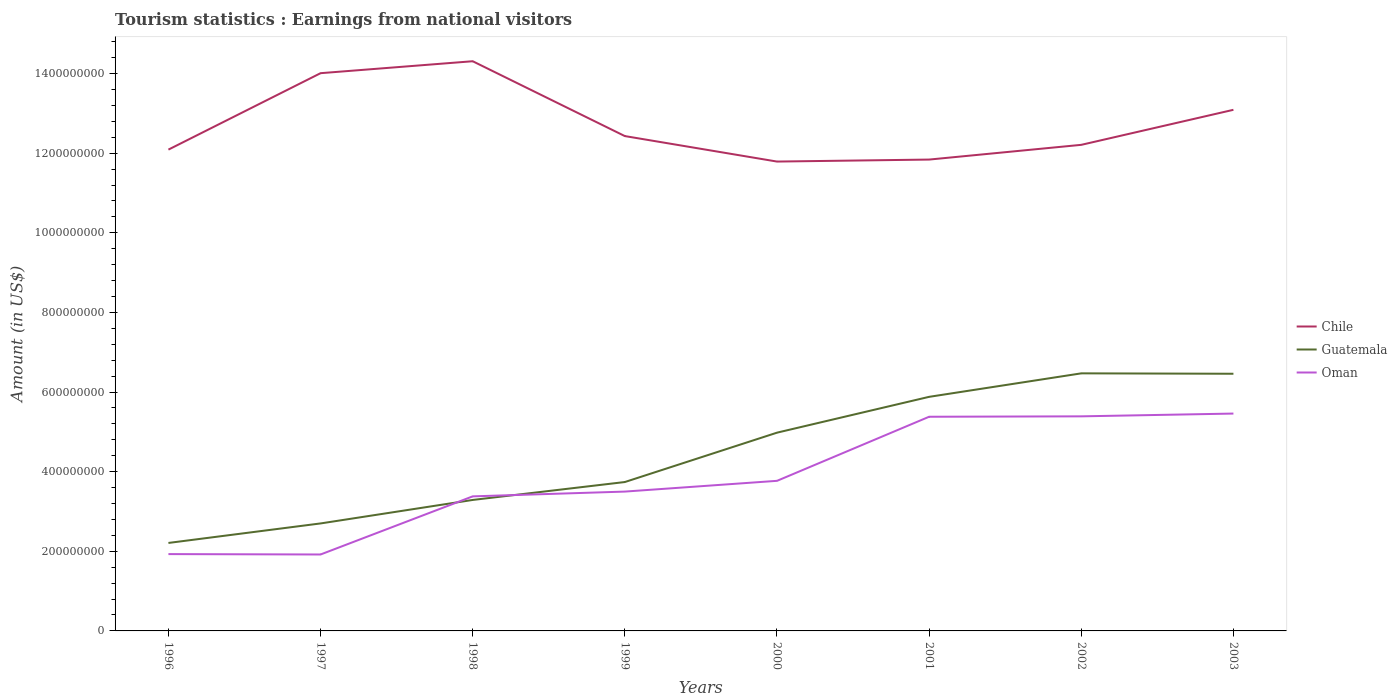Does the line corresponding to Chile intersect with the line corresponding to Guatemala?
Your response must be concise. No. Across all years, what is the maximum earnings from national visitors in Oman?
Keep it short and to the point. 1.92e+08. What is the total earnings from national visitors in Guatemala in the graph?
Offer a terse response. -4.26e+08. What is the difference between the highest and the second highest earnings from national visitors in Chile?
Offer a very short reply. 2.52e+08. Is the earnings from national visitors in Oman strictly greater than the earnings from national visitors in Guatemala over the years?
Make the answer very short. No. How many lines are there?
Give a very brief answer. 3. How many years are there in the graph?
Offer a terse response. 8. What is the difference between two consecutive major ticks on the Y-axis?
Provide a succinct answer. 2.00e+08. Are the values on the major ticks of Y-axis written in scientific E-notation?
Your answer should be very brief. No. Where does the legend appear in the graph?
Make the answer very short. Center right. How many legend labels are there?
Your answer should be very brief. 3. How are the legend labels stacked?
Your response must be concise. Vertical. What is the title of the graph?
Make the answer very short. Tourism statistics : Earnings from national visitors. What is the label or title of the X-axis?
Offer a very short reply. Years. What is the label or title of the Y-axis?
Keep it short and to the point. Amount (in US$). What is the Amount (in US$) of Chile in 1996?
Make the answer very short. 1.21e+09. What is the Amount (in US$) of Guatemala in 1996?
Your answer should be very brief. 2.21e+08. What is the Amount (in US$) in Oman in 1996?
Offer a terse response. 1.93e+08. What is the Amount (in US$) of Chile in 1997?
Your answer should be compact. 1.40e+09. What is the Amount (in US$) in Guatemala in 1997?
Provide a succinct answer. 2.70e+08. What is the Amount (in US$) of Oman in 1997?
Offer a terse response. 1.92e+08. What is the Amount (in US$) of Chile in 1998?
Your response must be concise. 1.43e+09. What is the Amount (in US$) in Guatemala in 1998?
Keep it short and to the point. 3.29e+08. What is the Amount (in US$) in Oman in 1998?
Ensure brevity in your answer.  3.38e+08. What is the Amount (in US$) of Chile in 1999?
Give a very brief answer. 1.24e+09. What is the Amount (in US$) of Guatemala in 1999?
Your answer should be very brief. 3.74e+08. What is the Amount (in US$) of Oman in 1999?
Your answer should be compact. 3.50e+08. What is the Amount (in US$) of Chile in 2000?
Provide a succinct answer. 1.18e+09. What is the Amount (in US$) of Guatemala in 2000?
Provide a succinct answer. 4.98e+08. What is the Amount (in US$) in Oman in 2000?
Your response must be concise. 3.77e+08. What is the Amount (in US$) of Chile in 2001?
Make the answer very short. 1.18e+09. What is the Amount (in US$) in Guatemala in 2001?
Give a very brief answer. 5.88e+08. What is the Amount (in US$) of Oman in 2001?
Provide a succinct answer. 5.38e+08. What is the Amount (in US$) of Chile in 2002?
Provide a succinct answer. 1.22e+09. What is the Amount (in US$) in Guatemala in 2002?
Make the answer very short. 6.47e+08. What is the Amount (in US$) in Oman in 2002?
Ensure brevity in your answer.  5.39e+08. What is the Amount (in US$) of Chile in 2003?
Offer a very short reply. 1.31e+09. What is the Amount (in US$) of Guatemala in 2003?
Give a very brief answer. 6.46e+08. What is the Amount (in US$) of Oman in 2003?
Provide a short and direct response. 5.46e+08. Across all years, what is the maximum Amount (in US$) of Chile?
Keep it short and to the point. 1.43e+09. Across all years, what is the maximum Amount (in US$) of Guatemala?
Your response must be concise. 6.47e+08. Across all years, what is the maximum Amount (in US$) of Oman?
Keep it short and to the point. 5.46e+08. Across all years, what is the minimum Amount (in US$) of Chile?
Offer a very short reply. 1.18e+09. Across all years, what is the minimum Amount (in US$) in Guatemala?
Give a very brief answer. 2.21e+08. Across all years, what is the minimum Amount (in US$) of Oman?
Keep it short and to the point. 1.92e+08. What is the total Amount (in US$) in Chile in the graph?
Offer a terse response. 1.02e+1. What is the total Amount (in US$) of Guatemala in the graph?
Offer a terse response. 3.57e+09. What is the total Amount (in US$) in Oman in the graph?
Your answer should be very brief. 3.07e+09. What is the difference between the Amount (in US$) of Chile in 1996 and that in 1997?
Provide a short and direct response. -1.92e+08. What is the difference between the Amount (in US$) in Guatemala in 1996 and that in 1997?
Provide a short and direct response. -4.90e+07. What is the difference between the Amount (in US$) of Oman in 1996 and that in 1997?
Give a very brief answer. 1.00e+06. What is the difference between the Amount (in US$) of Chile in 1996 and that in 1998?
Your answer should be very brief. -2.22e+08. What is the difference between the Amount (in US$) in Guatemala in 1996 and that in 1998?
Your answer should be compact. -1.08e+08. What is the difference between the Amount (in US$) in Oman in 1996 and that in 1998?
Provide a succinct answer. -1.45e+08. What is the difference between the Amount (in US$) of Chile in 1996 and that in 1999?
Your response must be concise. -3.40e+07. What is the difference between the Amount (in US$) of Guatemala in 1996 and that in 1999?
Your answer should be compact. -1.53e+08. What is the difference between the Amount (in US$) in Oman in 1996 and that in 1999?
Make the answer very short. -1.57e+08. What is the difference between the Amount (in US$) of Chile in 1996 and that in 2000?
Your answer should be compact. 3.00e+07. What is the difference between the Amount (in US$) in Guatemala in 1996 and that in 2000?
Provide a short and direct response. -2.77e+08. What is the difference between the Amount (in US$) in Oman in 1996 and that in 2000?
Provide a succinct answer. -1.84e+08. What is the difference between the Amount (in US$) of Chile in 1996 and that in 2001?
Give a very brief answer. 2.50e+07. What is the difference between the Amount (in US$) of Guatemala in 1996 and that in 2001?
Your answer should be very brief. -3.67e+08. What is the difference between the Amount (in US$) of Oman in 1996 and that in 2001?
Your response must be concise. -3.45e+08. What is the difference between the Amount (in US$) of Chile in 1996 and that in 2002?
Offer a very short reply. -1.20e+07. What is the difference between the Amount (in US$) in Guatemala in 1996 and that in 2002?
Your response must be concise. -4.26e+08. What is the difference between the Amount (in US$) in Oman in 1996 and that in 2002?
Provide a short and direct response. -3.46e+08. What is the difference between the Amount (in US$) in Chile in 1996 and that in 2003?
Make the answer very short. -1.00e+08. What is the difference between the Amount (in US$) in Guatemala in 1996 and that in 2003?
Give a very brief answer. -4.25e+08. What is the difference between the Amount (in US$) in Oman in 1996 and that in 2003?
Your answer should be compact. -3.53e+08. What is the difference between the Amount (in US$) of Chile in 1997 and that in 1998?
Your answer should be very brief. -3.00e+07. What is the difference between the Amount (in US$) in Guatemala in 1997 and that in 1998?
Your answer should be very brief. -5.90e+07. What is the difference between the Amount (in US$) of Oman in 1997 and that in 1998?
Provide a short and direct response. -1.46e+08. What is the difference between the Amount (in US$) in Chile in 1997 and that in 1999?
Your response must be concise. 1.58e+08. What is the difference between the Amount (in US$) of Guatemala in 1997 and that in 1999?
Your response must be concise. -1.04e+08. What is the difference between the Amount (in US$) of Oman in 1997 and that in 1999?
Ensure brevity in your answer.  -1.58e+08. What is the difference between the Amount (in US$) in Chile in 1997 and that in 2000?
Your answer should be very brief. 2.22e+08. What is the difference between the Amount (in US$) of Guatemala in 1997 and that in 2000?
Offer a very short reply. -2.28e+08. What is the difference between the Amount (in US$) in Oman in 1997 and that in 2000?
Your answer should be very brief. -1.85e+08. What is the difference between the Amount (in US$) of Chile in 1997 and that in 2001?
Ensure brevity in your answer.  2.17e+08. What is the difference between the Amount (in US$) of Guatemala in 1997 and that in 2001?
Provide a succinct answer. -3.18e+08. What is the difference between the Amount (in US$) in Oman in 1997 and that in 2001?
Make the answer very short. -3.46e+08. What is the difference between the Amount (in US$) in Chile in 1997 and that in 2002?
Keep it short and to the point. 1.80e+08. What is the difference between the Amount (in US$) of Guatemala in 1997 and that in 2002?
Offer a very short reply. -3.77e+08. What is the difference between the Amount (in US$) in Oman in 1997 and that in 2002?
Provide a short and direct response. -3.47e+08. What is the difference between the Amount (in US$) in Chile in 1997 and that in 2003?
Make the answer very short. 9.20e+07. What is the difference between the Amount (in US$) in Guatemala in 1997 and that in 2003?
Provide a succinct answer. -3.76e+08. What is the difference between the Amount (in US$) in Oman in 1997 and that in 2003?
Keep it short and to the point. -3.54e+08. What is the difference between the Amount (in US$) of Chile in 1998 and that in 1999?
Ensure brevity in your answer.  1.88e+08. What is the difference between the Amount (in US$) in Guatemala in 1998 and that in 1999?
Your response must be concise. -4.50e+07. What is the difference between the Amount (in US$) of Oman in 1998 and that in 1999?
Offer a terse response. -1.20e+07. What is the difference between the Amount (in US$) in Chile in 1998 and that in 2000?
Provide a succinct answer. 2.52e+08. What is the difference between the Amount (in US$) of Guatemala in 1998 and that in 2000?
Offer a terse response. -1.69e+08. What is the difference between the Amount (in US$) of Oman in 1998 and that in 2000?
Offer a terse response. -3.90e+07. What is the difference between the Amount (in US$) of Chile in 1998 and that in 2001?
Your answer should be very brief. 2.47e+08. What is the difference between the Amount (in US$) of Guatemala in 1998 and that in 2001?
Provide a succinct answer. -2.59e+08. What is the difference between the Amount (in US$) of Oman in 1998 and that in 2001?
Offer a very short reply. -2.00e+08. What is the difference between the Amount (in US$) in Chile in 1998 and that in 2002?
Give a very brief answer. 2.10e+08. What is the difference between the Amount (in US$) in Guatemala in 1998 and that in 2002?
Make the answer very short. -3.18e+08. What is the difference between the Amount (in US$) of Oman in 1998 and that in 2002?
Give a very brief answer. -2.01e+08. What is the difference between the Amount (in US$) of Chile in 1998 and that in 2003?
Provide a succinct answer. 1.22e+08. What is the difference between the Amount (in US$) of Guatemala in 1998 and that in 2003?
Provide a short and direct response. -3.17e+08. What is the difference between the Amount (in US$) of Oman in 1998 and that in 2003?
Ensure brevity in your answer.  -2.08e+08. What is the difference between the Amount (in US$) in Chile in 1999 and that in 2000?
Offer a very short reply. 6.40e+07. What is the difference between the Amount (in US$) in Guatemala in 1999 and that in 2000?
Provide a succinct answer. -1.24e+08. What is the difference between the Amount (in US$) in Oman in 1999 and that in 2000?
Your response must be concise. -2.70e+07. What is the difference between the Amount (in US$) in Chile in 1999 and that in 2001?
Offer a terse response. 5.90e+07. What is the difference between the Amount (in US$) in Guatemala in 1999 and that in 2001?
Your answer should be very brief. -2.14e+08. What is the difference between the Amount (in US$) of Oman in 1999 and that in 2001?
Your answer should be very brief. -1.88e+08. What is the difference between the Amount (in US$) of Chile in 1999 and that in 2002?
Keep it short and to the point. 2.20e+07. What is the difference between the Amount (in US$) of Guatemala in 1999 and that in 2002?
Your answer should be compact. -2.73e+08. What is the difference between the Amount (in US$) of Oman in 1999 and that in 2002?
Offer a very short reply. -1.89e+08. What is the difference between the Amount (in US$) in Chile in 1999 and that in 2003?
Give a very brief answer. -6.60e+07. What is the difference between the Amount (in US$) of Guatemala in 1999 and that in 2003?
Your answer should be very brief. -2.72e+08. What is the difference between the Amount (in US$) in Oman in 1999 and that in 2003?
Your answer should be compact. -1.96e+08. What is the difference between the Amount (in US$) in Chile in 2000 and that in 2001?
Your answer should be compact. -5.00e+06. What is the difference between the Amount (in US$) in Guatemala in 2000 and that in 2001?
Provide a succinct answer. -9.00e+07. What is the difference between the Amount (in US$) of Oman in 2000 and that in 2001?
Your answer should be very brief. -1.61e+08. What is the difference between the Amount (in US$) of Chile in 2000 and that in 2002?
Offer a terse response. -4.20e+07. What is the difference between the Amount (in US$) of Guatemala in 2000 and that in 2002?
Your answer should be very brief. -1.49e+08. What is the difference between the Amount (in US$) in Oman in 2000 and that in 2002?
Keep it short and to the point. -1.62e+08. What is the difference between the Amount (in US$) of Chile in 2000 and that in 2003?
Make the answer very short. -1.30e+08. What is the difference between the Amount (in US$) of Guatemala in 2000 and that in 2003?
Your answer should be compact. -1.48e+08. What is the difference between the Amount (in US$) in Oman in 2000 and that in 2003?
Offer a very short reply. -1.69e+08. What is the difference between the Amount (in US$) of Chile in 2001 and that in 2002?
Make the answer very short. -3.70e+07. What is the difference between the Amount (in US$) in Guatemala in 2001 and that in 2002?
Your response must be concise. -5.90e+07. What is the difference between the Amount (in US$) in Chile in 2001 and that in 2003?
Offer a very short reply. -1.25e+08. What is the difference between the Amount (in US$) in Guatemala in 2001 and that in 2003?
Offer a terse response. -5.80e+07. What is the difference between the Amount (in US$) of Oman in 2001 and that in 2003?
Keep it short and to the point. -8.00e+06. What is the difference between the Amount (in US$) of Chile in 2002 and that in 2003?
Provide a short and direct response. -8.80e+07. What is the difference between the Amount (in US$) of Guatemala in 2002 and that in 2003?
Your answer should be compact. 1.00e+06. What is the difference between the Amount (in US$) of Oman in 2002 and that in 2003?
Provide a short and direct response. -7.00e+06. What is the difference between the Amount (in US$) of Chile in 1996 and the Amount (in US$) of Guatemala in 1997?
Provide a short and direct response. 9.39e+08. What is the difference between the Amount (in US$) in Chile in 1996 and the Amount (in US$) in Oman in 1997?
Offer a very short reply. 1.02e+09. What is the difference between the Amount (in US$) of Guatemala in 1996 and the Amount (in US$) of Oman in 1997?
Provide a succinct answer. 2.90e+07. What is the difference between the Amount (in US$) of Chile in 1996 and the Amount (in US$) of Guatemala in 1998?
Your answer should be compact. 8.80e+08. What is the difference between the Amount (in US$) in Chile in 1996 and the Amount (in US$) in Oman in 1998?
Provide a succinct answer. 8.71e+08. What is the difference between the Amount (in US$) of Guatemala in 1996 and the Amount (in US$) of Oman in 1998?
Your answer should be compact. -1.17e+08. What is the difference between the Amount (in US$) of Chile in 1996 and the Amount (in US$) of Guatemala in 1999?
Make the answer very short. 8.35e+08. What is the difference between the Amount (in US$) in Chile in 1996 and the Amount (in US$) in Oman in 1999?
Your answer should be very brief. 8.59e+08. What is the difference between the Amount (in US$) in Guatemala in 1996 and the Amount (in US$) in Oman in 1999?
Your response must be concise. -1.29e+08. What is the difference between the Amount (in US$) of Chile in 1996 and the Amount (in US$) of Guatemala in 2000?
Offer a very short reply. 7.11e+08. What is the difference between the Amount (in US$) of Chile in 1996 and the Amount (in US$) of Oman in 2000?
Ensure brevity in your answer.  8.32e+08. What is the difference between the Amount (in US$) in Guatemala in 1996 and the Amount (in US$) in Oman in 2000?
Ensure brevity in your answer.  -1.56e+08. What is the difference between the Amount (in US$) in Chile in 1996 and the Amount (in US$) in Guatemala in 2001?
Make the answer very short. 6.21e+08. What is the difference between the Amount (in US$) in Chile in 1996 and the Amount (in US$) in Oman in 2001?
Offer a very short reply. 6.71e+08. What is the difference between the Amount (in US$) in Guatemala in 1996 and the Amount (in US$) in Oman in 2001?
Make the answer very short. -3.17e+08. What is the difference between the Amount (in US$) in Chile in 1996 and the Amount (in US$) in Guatemala in 2002?
Keep it short and to the point. 5.62e+08. What is the difference between the Amount (in US$) of Chile in 1996 and the Amount (in US$) of Oman in 2002?
Give a very brief answer. 6.70e+08. What is the difference between the Amount (in US$) in Guatemala in 1996 and the Amount (in US$) in Oman in 2002?
Make the answer very short. -3.18e+08. What is the difference between the Amount (in US$) in Chile in 1996 and the Amount (in US$) in Guatemala in 2003?
Keep it short and to the point. 5.63e+08. What is the difference between the Amount (in US$) of Chile in 1996 and the Amount (in US$) of Oman in 2003?
Provide a succinct answer. 6.63e+08. What is the difference between the Amount (in US$) of Guatemala in 1996 and the Amount (in US$) of Oman in 2003?
Offer a terse response. -3.25e+08. What is the difference between the Amount (in US$) of Chile in 1997 and the Amount (in US$) of Guatemala in 1998?
Provide a short and direct response. 1.07e+09. What is the difference between the Amount (in US$) of Chile in 1997 and the Amount (in US$) of Oman in 1998?
Keep it short and to the point. 1.06e+09. What is the difference between the Amount (in US$) in Guatemala in 1997 and the Amount (in US$) in Oman in 1998?
Make the answer very short. -6.80e+07. What is the difference between the Amount (in US$) in Chile in 1997 and the Amount (in US$) in Guatemala in 1999?
Your answer should be compact. 1.03e+09. What is the difference between the Amount (in US$) of Chile in 1997 and the Amount (in US$) of Oman in 1999?
Your response must be concise. 1.05e+09. What is the difference between the Amount (in US$) in Guatemala in 1997 and the Amount (in US$) in Oman in 1999?
Your response must be concise. -8.00e+07. What is the difference between the Amount (in US$) of Chile in 1997 and the Amount (in US$) of Guatemala in 2000?
Keep it short and to the point. 9.03e+08. What is the difference between the Amount (in US$) in Chile in 1997 and the Amount (in US$) in Oman in 2000?
Your answer should be very brief. 1.02e+09. What is the difference between the Amount (in US$) in Guatemala in 1997 and the Amount (in US$) in Oman in 2000?
Your response must be concise. -1.07e+08. What is the difference between the Amount (in US$) of Chile in 1997 and the Amount (in US$) of Guatemala in 2001?
Make the answer very short. 8.13e+08. What is the difference between the Amount (in US$) of Chile in 1997 and the Amount (in US$) of Oman in 2001?
Ensure brevity in your answer.  8.63e+08. What is the difference between the Amount (in US$) in Guatemala in 1997 and the Amount (in US$) in Oman in 2001?
Your answer should be compact. -2.68e+08. What is the difference between the Amount (in US$) of Chile in 1997 and the Amount (in US$) of Guatemala in 2002?
Offer a very short reply. 7.54e+08. What is the difference between the Amount (in US$) of Chile in 1997 and the Amount (in US$) of Oman in 2002?
Provide a short and direct response. 8.62e+08. What is the difference between the Amount (in US$) in Guatemala in 1997 and the Amount (in US$) in Oman in 2002?
Make the answer very short. -2.69e+08. What is the difference between the Amount (in US$) of Chile in 1997 and the Amount (in US$) of Guatemala in 2003?
Your response must be concise. 7.55e+08. What is the difference between the Amount (in US$) in Chile in 1997 and the Amount (in US$) in Oman in 2003?
Your answer should be very brief. 8.55e+08. What is the difference between the Amount (in US$) of Guatemala in 1997 and the Amount (in US$) of Oman in 2003?
Offer a terse response. -2.76e+08. What is the difference between the Amount (in US$) of Chile in 1998 and the Amount (in US$) of Guatemala in 1999?
Your response must be concise. 1.06e+09. What is the difference between the Amount (in US$) in Chile in 1998 and the Amount (in US$) in Oman in 1999?
Offer a very short reply. 1.08e+09. What is the difference between the Amount (in US$) of Guatemala in 1998 and the Amount (in US$) of Oman in 1999?
Keep it short and to the point. -2.10e+07. What is the difference between the Amount (in US$) in Chile in 1998 and the Amount (in US$) in Guatemala in 2000?
Provide a short and direct response. 9.33e+08. What is the difference between the Amount (in US$) in Chile in 1998 and the Amount (in US$) in Oman in 2000?
Keep it short and to the point. 1.05e+09. What is the difference between the Amount (in US$) in Guatemala in 1998 and the Amount (in US$) in Oman in 2000?
Offer a terse response. -4.80e+07. What is the difference between the Amount (in US$) of Chile in 1998 and the Amount (in US$) of Guatemala in 2001?
Your answer should be compact. 8.43e+08. What is the difference between the Amount (in US$) in Chile in 1998 and the Amount (in US$) in Oman in 2001?
Offer a terse response. 8.93e+08. What is the difference between the Amount (in US$) of Guatemala in 1998 and the Amount (in US$) of Oman in 2001?
Give a very brief answer. -2.09e+08. What is the difference between the Amount (in US$) of Chile in 1998 and the Amount (in US$) of Guatemala in 2002?
Give a very brief answer. 7.84e+08. What is the difference between the Amount (in US$) of Chile in 1998 and the Amount (in US$) of Oman in 2002?
Make the answer very short. 8.92e+08. What is the difference between the Amount (in US$) of Guatemala in 1998 and the Amount (in US$) of Oman in 2002?
Provide a succinct answer. -2.10e+08. What is the difference between the Amount (in US$) in Chile in 1998 and the Amount (in US$) in Guatemala in 2003?
Your response must be concise. 7.85e+08. What is the difference between the Amount (in US$) of Chile in 1998 and the Amount (in US$) of Oman in 2003?
Provide a short and direct response. 8.85e+08. What is the difference between the Amount (in US$) of Guatemala in 1998 and the Amount (in US$) of Oman in 2003?
Keep it short and to the point. -2.17e+08. What is the difference between the Amount (in US$) of Chile in 1999 and the Amount (in US$) of Guatemala in 2000?
Your answer should be very brief. 7.45e+08. What is the difference between the Amount (in US$) in Chile in 1999 and the Amount (in US$) in Oman in 2000?
Ensure brevity in your answer.  8.66e+08. What is the difference between the Amount (in US$) of Chile in 1999 and the Amount (in US$) of Guatemala in 2001?
Ensure brevity in your answer.  6.55e+08. What is the difference between the Amount (in US$) in Chile in 1999 and the Amount (in US$) in Oman in 2001?
Keep it short and to the point. 7.05e+08. What is the difference between the Amount (in US$) of Guatemala in 1999 and the Amount (in US$) of Oman in 2001?
Ensure brevity in your answer.  -1.64e+08. What is the difference between the Amount (in US$) of Chile in 1999 and the Amount (in US$) of Guatemala in 2002?
Your response must be concise. 5.96e+08. What is the difference between the Amount (in US$) of Chile in 1999 and the Amount (in US$) of Oman in 2002?
Your answer should be compact. 7.04e+08. What is the difference between the Amount (in US$) in Guatemala in 1999 and the Amount (in US$) in Oman in 2002?
Offer a very short reply. -1.65e+08. What is the difference between the Amount (in US$) in Chile in 1999 and the Amount (in US$) in Guatemala in 2003?
Ensure brevity in your answer.  5.97e+08. What is the difference between the Amount (in US$) in Chile in 1999 and the Amount (in US$) in Oman in 2003?
Your response must be concise. 6.97e+08. What is the difference between the Amount (in US$) of Guatemala in 1999 and the Amount (in US$) of Oman in 2003?
Your answer should be very brief. -1.72e+08. What is the difference between the Amount (in US$) of Chile in 2000 and the Amount (in US$) of Guatemala in 2001?
Make the answer very short. 5.91e+08. What is the difference between the Amount (in US$) in Chile in 2000 and the Amount (in US$) in Oman in 2001?
Ensure brevity in your answer.  6.41e+08. What is the difference between the Amount (in US$) of Guatemala in 2000 and the Amount (in US$) of Oman in 2001?
Offer a very short reply. -4.00e+07. What is the difference between the Amount (in US$) in Chile in 2000 and the Amount (in US$) in Guatemala in 2002?
Your answer should be very brief. 5.32e+08. What is the difference between the Amount (in US$) of Chile in 2000 and the Amount (in US$) of Oman in 2002?
Provide a succinct answer. 6.40e+08. What is the difference between the Amount (in US$) of Guatemala in 2000 and the Amount (in US$) of Oman in 2002?
Your response must be concise. -4.10e+07. What is the difference between the Amount (in US$) in Chile in 2000 and the Amount (in US$) in Guatemala in 2003?
Provide a succinct answer. 5.33e+08. What is the difference between the Amount (in US$) in Chile in 2000 and the Amount (in US$) in Oman in 2003?
Give a very brief answer. 6.33e+08. What is the difference between the Amount (in US$) in Guatemala in 2000 and the Amount (in US$) in Oman in 2003?
Offer a terse response. -4.80e+07. What is the difference between the Amount (in US$) in Chile in 2001 and the Amount (in US$) in Guatemala in 2002?
Provide a succinct answer. 5.37e+08. What is the difference between the Amount (in US$) of Chile in 2001 and the Amount (in US$) of Oman in 2002?
Keep it short and to the point. 6.45e+08. What is the difference between the Amount (in US$) in Guatemala in 2001 and the Amount (in US$) in Oman in 2002?
Provide a short and direct response. 4.90e+07. What is the difference between the Amount (in US$) of Chile in 2001 and the Amount (in US$) of Guatemala in 2003?
Offer a very short reply. 5.38e+08. What is the difference between the Amount (in US$) of Chile in 2001 and the Amount (in US$) of Oman in 2003?
Make the answer very short. 6.38e+08. What is the difference between the Amount (in US$) of Guatemala in 2001 and the Amount (in US$) of Oman in 2003?
Give a very brief answer. 4.20e+07. What is the difference between the Amount (in US$) in Chile in 2002 and the Amount (in US$) in Guatemala in 2003?
Provide a succinct answer. 5.75e+08. What is the difference between the Amount (in US$) of Chile in 2002 and the Amount (in US$) of Oman in 2003?
Offer a terse response. 6.75e+08. What is the difference between the Amount (in US$) of Guatemala in 2002 and the Amount (in US$) of Oman in 2003?
Provide a succinct answer. 1.01e+08. What is the average Amount (in US$) of Chile per year?
Offer a very short reply. 1.27e+09. What is the average Amount (in US$) of Guatemala per year?
Provide a short and direct response. 4.47e+08. What is the average Amount (in US$) in Oman per year?
Your response must be concise. 3.84e+08. In the year 1996, what is the difference between the Amount (in US$) of Chile and Amount (in US$) of Guatemala?
Give a very brief answer. 9.88e+08. In the year 1996, what is the difference between the Amount (in US$) of Chile and Amount (in US$) of Oman?
Your response must be concise. 1.02e+09. In the year 1996, what is the difference between the Amount (in US$) of Guatemala and Amount (in US$) of Oman?
Ensure brevity in your answer.  2.80e+07. In the year 1997, what is the difference between the Amount (in US$) of Chile and Amount (in US$) of Guatemala?
Offer a terse response. 1.13e+09. In the year 1997, what is the difference between the Amount (in US$) of Chile and Amount (in US$) of Oman?
Offer a very short reply. 1.21e+09. In the year 1997, what is the difference between the Amount (in US$) in Guatemala and Amount (in US$) in Oman?
Offer a very short reply. 7.80e+07. In the year 1998, what is the difference between the Amount (in US$) in Chile and Amount (in US$) in Guatemala?
Offer a very short reply. 1.10e+09. In the year 1998, what is the difference between the Amount (in US$) of Chile and Amount (in US$) of Oman?
Keep it short and to the point. 1.09e+09. In the year 1998, what is the difference between the Amount (in US$) in Guatemala and Amount (in US$) in Oman?
Give a very brief answer. -9.00e+06. In the year 1999, what is the difference between the Amount (in US$) in Chile and Amount (in US$) in Guatemala?
Your response must be concise. 8.69e+08. In the year 1999, what is the difference between the Amount (in US$) in Chile and Amount (in US$) in Oman?
Provide a short and direct response. 8.93e+08. In the year 1999, what is the difference between the Amount (in US$) in Guatemala and Amount (in US$) in Oman?
Give a very brief answer. 2.40e+07. In the year 2000, what is the difference between the Amount (in US$) in Chile and Amount (in US$) in Guatemala?
Offer a very short reply. 6.81e+08. In the year 2000, what is the difference between the Amount (in US$) of Chile and Amount (in US$) of Oman?
Offer a very short reply. 8.02e+08. In the year 2000, what is the difference between the Amount (in US$) of Guatemala and Amount (in US$) of Oman?
Your answer should be very brief. 1.21e+08. In the year 2001, what is the difference between the Amount (in US$) of Chile and Amount (in US$) of Guatemala?
Keep it short and to the point. 5.96e+08. In the year 2001, what is the difference between the Amount (in US$) of Chile and Amount (in US$) of Oman?
Provide a succinct answer. 6.46e+08. In the year 2002, what is the difference between the Amount (in US$) of Chile and Amount (in US$) of Guatemala?
Provide a short and direct response. 5.74e+08. In the year 2002, what is the difference between the Amount (in US$) of Chile and Amount (in US$) of Oman?
Give a very brief answer. 6.82e+08. In the year 2002, what is the difference between the Amount (in US$) of Guatemala and Amount (in US$) of Oman?
Your answer should be compact. 1.08e+08. In the year 2003, what is the difference between the Amount (in US$) in Chile and Amount (in US$) in Guatemala?
Your response must be concise. 6.63e+08. In the year 2003, what is the difference between the Amount (in US$) in Chile and Amount (in US$) in Oman?
Offer a terse response. 7.63e+08. In the year 2003, what is the difference between the Amount (in US$) in Guatemala and Amount (in US$) in Oman?
Keep it short and to the point. 1.00e+08. What is the ratio of the Amount (in US$) of Chile in 1996 to that in 1997?
Your response must be concise. 0.86. What is the ratio of the Amount (in US$) of Guatemala in 1996 to that in 1997?
Your answer should be very brief. 0.82. What is the ratio of the Amount (in US$) of Oman in 1996 to that in 1997?
Provide a short and direct response. 1.01. What is the ratio of the Amount (in US$) in Chile in 1996 to that in 1998?
Ensure brevity in your answer.  0.84. What is the ratio of the Amount (in US$) of Guatemala in 1996 to that in 1998?
Your response must be concise. 0.67. What is the ratio of the Amount (in US$) of Oman in 1996 to that in 1998?
Provide a short and direct response. 0.57. What is the ratio of the Amount (in US$) in Chile in 1996 to that in 1999?
Offer a very short reply. 0.97. What is the ratio of the Amount (in US$) of Guatemala in 1996 to that in 1999?
Your answer should be compact. 0.59. What is the ratio of the Amount (in US$) of Oman in 1996 to that in 1999?
Your answer should be compact. 0.55. What is the ratio of the Amount (in US$) in Chile in 1996 to that in 2000?
Give a very brief answer. 1.03. What is the ratio of the Amount (in US$) of Guatemala in 1996 to that in 2000?
Ensure brevity in your answer.  0.44. What is the ratio of the Amount (in US$) in Oman in 1996 to that in 2000?
Your answer should be very brief. 0.51. What is the ratio of the Amount (in US$) of Chile in 1996 to that in 2001?
Provide a short and direct response. 1.02. What is the ratio of the Amount (in US$) in Guatemala in 1996 to that in 2001?
Ensure brevity in your answer.  0.38. What is the ratio of the Amount (in US$) in Oman in 1996 to that in 2001?
Offer a very short reply. 0.36. What is the ratio of the Amount (in US$) in Chile in 1996 to that in 2002?
Keep it short and to the point. 0.99. What is the ratio of the Amount (in US$) of Guatemala in 1996 to that in 2002?
Your answer should be compact. 0.34. What is the ratio of the Amount (in US$) of Oman in 1996 to that in 2002?
Give a very brief answer. 0.36. What is the ratio of the Amount (in US$) of Chile in 1996 to that in 2003?
Offer a very short reply. 0.92. What is the ratio of the Amount (in US$) in Guatemala in 1996 to that in 2003?
Your answer should be compact. 0.34. What is the ratio of the Amount (in US$) in Oman in 1996 to that in 2003?
Your answer should be compact. 0.35. What is the ratio of the Amount (in US$) of Guatemala in 1997 to that in 1998?
Your answer should be very brief. 0.82. What is the ratio of the Amount (in US$) in Oman in 1997 to that in 1998?
Offer a terse response. 0.57. What is the ratio of the Amount (in US$) in Chile in 1997 to that in 1999?
Offer a very short reply. 1.13. What is the ratio of the Amount (in US$) in Guatemala in 1997 to that in 1999?
Keep it short and to the point. 0.72. What is the ratio of the Amount (in US$) of Oman in 1997 to that in 1999?
Your response must be concise. 0.55. What is the ratio of the Amount (in US$) of Chile in 1997 to that in 2000?
Offer a very short reply. 1.19. What is the ratio of the Amount (in US$) of Guatemala in 1997 to that in 2000?
Offer a very short reply. 0.54. What is the ratio of the Amount (in US$) of Oman in 1997 to that in 2000?
Your response must be concise. 0.51. What is the ratio of the Amount (in US$) in Chile in 1997 to that in 2001?
Your response must be concise. 1.18. What is the ratio of the Amount (in US$) of Guatemala in 1997 to that in 2001?
Give a very brief answer. 0.46. What is the ratio of the Amount (in US$) in Oman in 1997 to that in 2001?
Give a very brief answer. 0.36. What is the ratio of the Amount (in US$) of Chile in 1997 to that in 2002?
Give a very brief answer. 1.15. What is the ratio of the Amount (in US$) of Guatemala in 1997 to that in 2002?
Provide a short and direct response. 0.42. What is the ratio of the Amount (in US$) in Oman in 1997 to that in 2002?
Make the answer very short. 0.36. What is the ratio of the Amount (in US$) of Chile in 1997 to that in 2003?
Your response must be concise. 1.07. What is the ratio of the Amount (in US$) in Guatemala in 1997 to that in 2003?
Provide a short and direct response. 0.42. What is the ratio of the Amount (in US$) in Oman in 1997 to that in 2003?
Offer a terse response. 0.35. What is the ratio of the Amount (in US$) in Chile in 1998 to that in 1999?
Your answer should be very brief. 1.15. What is the ratio of the Amount (in US$) in Guatemala in 1998 to that in 1999?
Your answer should be compact. 0.88. What is the ratio of the Amount (in US$) in Oman in 1998 to that in 1999?
Offer a very short reply. 0.97. What is the ratio of the Amount (in US$) of Chile in 1998 to that in 2000?
Offer a terse response. 1.21. What is the ratio of the Amount (in US$) in Guatemala in 1998 to that in 2000?
Give a very brief answer. 0.66. What is the ratio of the Amount (in US$) of Oman in 1998 to that in 2000?
Provide a short and direct response. 0.9. What is the ratio of the Amount (in US$) in Chile in 1998 to that in 2001?
Provide a succinct answer. 1.21. What is the ratio of the Amount (in US$) of Guatemala in 1998 to that in 2001?
Provide a succinct answer. 0.56. What is the ratio of the Amount (in US$) in Oman in 1998 to that in 2001?
Your response must be concise. 0.63. What is the ratio of the Amount (in US$) of Chile in 1998 to that in 2002?
Offer a terse response. 1.17. What is the ratio of the Amount (in US$) in Guatemala in 1998 to that in 2002?
Give a very brief answer. 0.51. What is the ratio of the Amount (in US$) of Oman in 1998 to that in 2002?
Offer a very short reply. 0.63. What is the ratio of the Amount (in US$) in Chile in 1998 to that in 2003?
Offer a terse response. 1.09. What is the ratio of the Amount (in US$) in Guatemala in 1998 to that in 2003?
Your answer should be very brief. 0.51. What is the ratio of the Amount (in US$) in Oman in 1998 to that in 2003?
Provide a succinct answer. 0.62. What is the ratio of the Amount (in US$) in Chile in 1999 to that in 2000?
Your response must be concise. 1.05. What is the ratio of the Amount (in US$) of Guatemala in 1999 to that in 2000?
Make the answer very short. 0.75. What is the ratio of the Amount (in US$) of Oman in 1999 to that in 2000?
Your response must be concise. 0.93. What is the ratio of the Amount (in US$) of Chile in 1999 to that in 2001?
Provide a short and direct response. 1.05. What is the ratio of the Amount (in US$) of Guatemala in 1999 to that in 2001?
Your response must be concise. 0.64. What is the ratio of the Amount (in US$) of Oman in 1999 to that in 2001?
Your answer should be compact. 0.65. What is the ratio of the Amount (in US$) of Guatemala in 1999 to that in 2002?
Ensure brevity in your answer.  0.58. What is the ratio of the Amount (in US$) in Oman in 1999 to that in 2002?
Give a very brief answer. 0.65. What is the ratio of the Amount (in US$) in Chile in 1999 to that in 2003?
Keep it short and to the point. 0.95. What is the ratio of the Amount (in US$) in Guatemala in 1999 to that in 2003?
Your response must be concise. 0.58. What is the ratio of the Amount (in US$) of Oman in 1999 to that in 2003?
Ensure brevity in your answer.  0.64. What is the ratio of the Amount (in US$) in Guatemala in 2000 to that in 2001?
Make the answer very short. 0.85. What is the ratio of the Amount (in US$) in Oman in 2000 to that in 2001?
Offer a terse response. 0.7. What is the ratio of the Amount (in US$) of Chile in 2000 to that in 2002?
Keep it short and to the point. 0.97. What is the ratio of the Amount (in US$) of Guatemala in 2000 to that in 2002?
Make the answer very short. 0.77. What is the ratio of the Amount (in US$) of Oman in 2000 to that in 2002?
Your answer should be compact. 0.7. What is the ratio of the Amount (in US$) of Chile in 2000 to that in 2003?
Offer a very short reply. 0.9. What is the ratio of the Amount (in US$) in Guatemala in 2000 to that in 2003?
Make the answer very short. 0.77. What is the ratio of the Amount (in US$) in Oman in 2000 to that in 2003?
Ensure brevity in your answer.  0.69. What is the ratio of the Amount (in US$) in Chile in 2001 to that in 2002?
Make the answer very short. 0.97. What is the ratio of the Amount (in US$) of Guatemala in 2001 to that in 2002?
Your answer should be compact. 0.91. What is the ratio of the Amount (in US$) in Oman in 2001 to that in 2002?
Offer a very short reply. 1. What is the ratio of the Amount (in US$) of Chile in 2001 to that in 2003?
Your response must be concise. 0.9. What is the ratio of the Amount (in US$) in Guatemala in 2001 to that in 2003?
Ensure brevity in your answer.  0.91. What is the ratio of the Amount (in US$) of Chile in 2002 to that in 2003?
Provide a short and direct response. 0.93. What is the ratio of the Amount (in US$) in Guatemala in 2002 to that in 2003?
Your response must be concise. 1. What is the ratio of the Amount (in US$) in Oman in 2002 to that in 2003?
Your answer should be very brief. 0.99. What is the difference between the highest and the second highest Amount (in US$) of Chile?
Your answer should be very brief. 3.00e+07. What is the difference between the highest and the lowest Amount (in US$) of Chile?
Your response must be concise. 2.52e+08. What is the difference between the highest and the lowest Amount (in US$) of Guatemala?
Provide a short and direct response. 4.26e+08. What is the difference between the highest and the lowest Amount (in US$) in Oman?
Your answer should be very brief. 3.54e+08. 